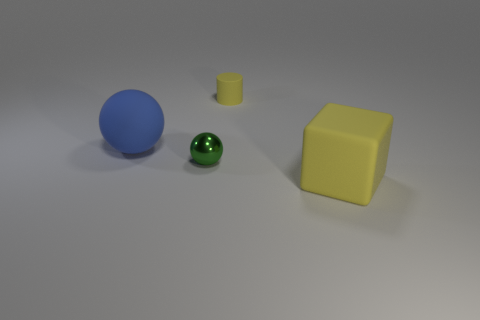Is there anything else that is the same shape as the small yellow rubber thing?
Make the answer very short. No. How many things are either green spheres or purple rubber blocks?
Offer a terse response. 1. There is a shiny object; is its size the same as the yellow thing that is behind the small shiny sphere?
Your answer should be very brief. Yes. What is the color of the small thing that is in front of the yellow thing that is behind the big object right of the yellow cylinder?
Offer a very short reply. Green. What is the color of the big sphere?
Your answer should be compact. Blue. Are there more yellow matte cylinders on the right side of the small cylinder than big blue matte spheres that are right of the small green metal sphere?
Provide a succinct answer. No. Does the small green thing have the same shape as the large thing that is to the left of the tiny yellow rubber thing?
Make the answer very short. Yes. Do the yellow thing on the right side of the yellow rubber cylinder and the yellow matte thing behind the small shiny sphere have the same size?
Your answer should be compact. No. There is a yellow thing that is to the left of the yellow rubber object that is in front of the tiny green object; are there any yellow rubber cylinders that are to the left of it?
Your response must be concise. No. Are there fewer yellow blocks that are to the left of the tiny yellow matte thing than large balls that are right of the rubber sphere?
Provide a succinct answer. No. 